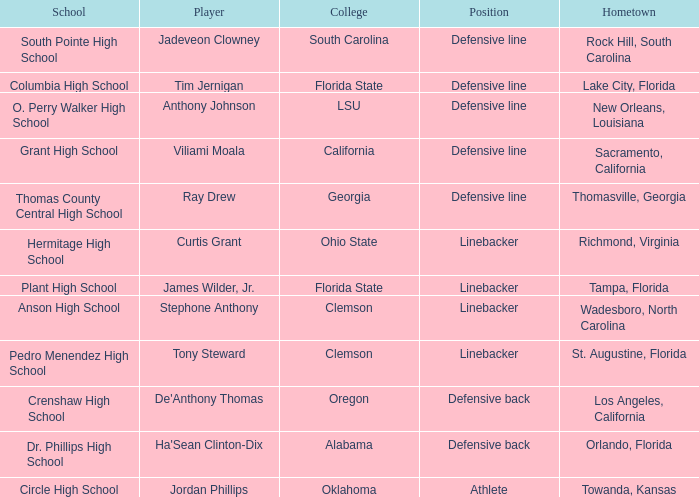What is the hometown of a player associated with ray drew? Thomasville, Georgia. 